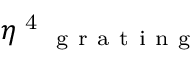<formula> <loc_0><loc_0><loc_500><loc_500>\eta \text  superscript { 4 } _ { g r a t i n g }</formula> 